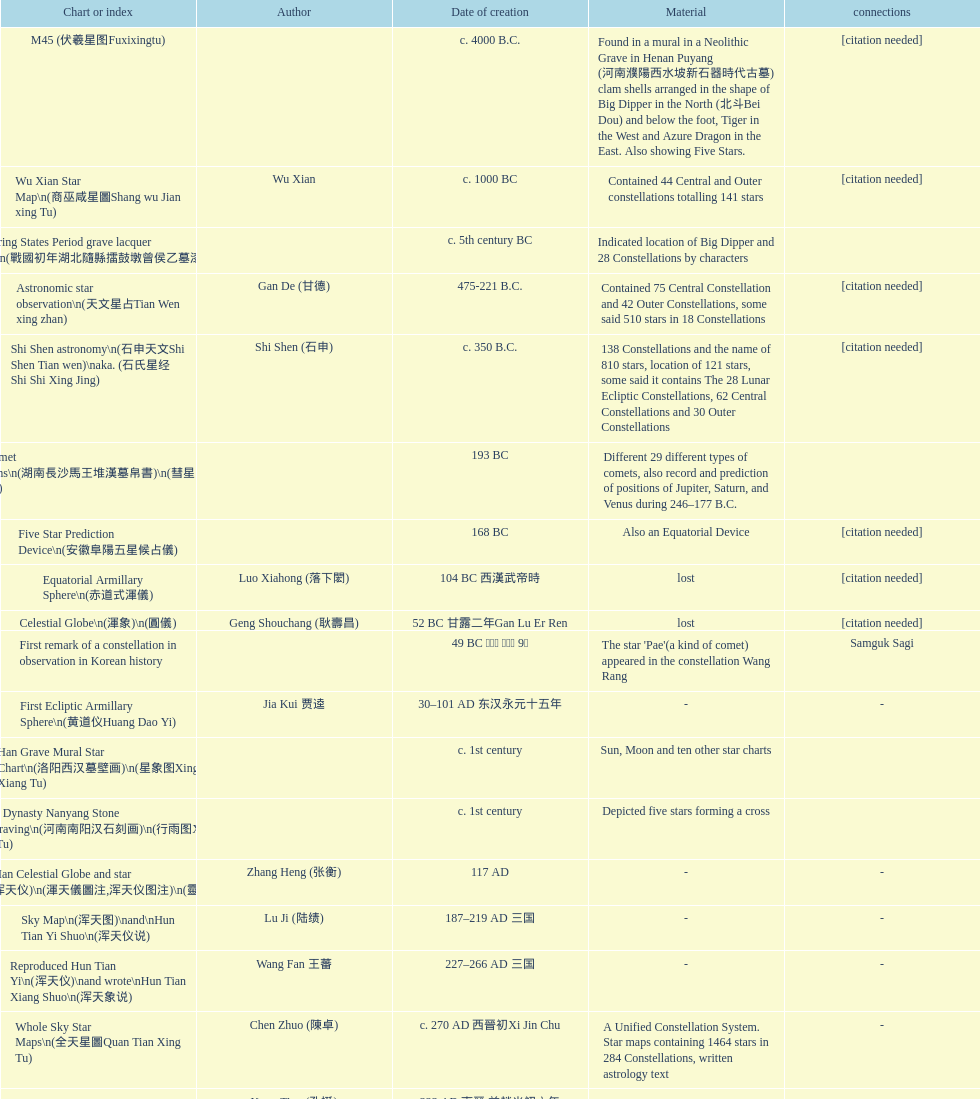Which map or catalog was created last? Sky in Google Earth KML. 